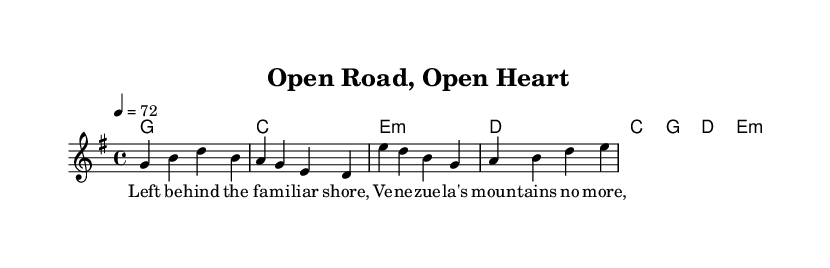What is the key signature of this music? The key signature is G major, which has one sharp (F#). This can be determined by looking at the key signature indicated at the beginning of the score.
Answer: G major What is the time signature of this music? The time signature is 4/4, meaning there are four beats in each measure and the quarter note gets one beat. This is clearly stated at the beginning next to the key signature.
Answer: 4/4 What is the tempo marking of this music? The tempo marking is 72 beats per minute, indicated by the tempo text "4 = 72" which shows the speed at which the piece should be played.
Answer: 72 How many measures are in the verse melody? The verse melody consists of two measures, determined by counting the separate groups divided by vertical lines (bar lines) in the given melodic segment.
Answer: 2 What is the first chord in the verse progression? The first chord in the verse progression is G major, which is indicated by the chord symbols above the melody for the first measure.
Answer: G What theme does the chorus lyrics convey? The chorus lyrics convey a theme of dreaming and perception of life, as expressed in the lyrics “On the open road, chasing dreams, Life's not always what it seems.” This reflects an adventure and new beginnings.
Answer: Adventure How does the overall structure of this piece reflect Southern rock ballads? The song combines narrative elements and emotive themes typical of Southern rock ballads, characterized by a storytelling approach and focus on personal journeys and transformations, evident in both the lyrics and the chord progression.
Answer: Storytelling 